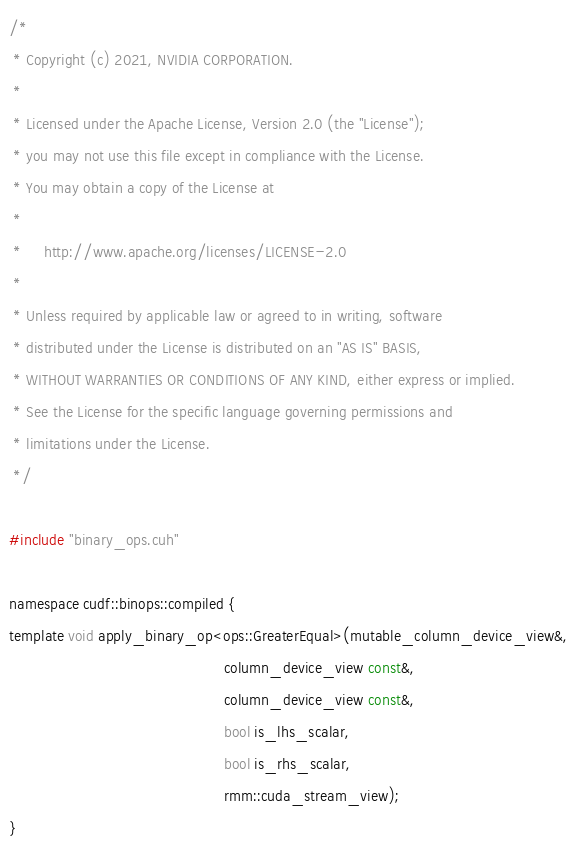<code> <loc_0><loc_0><loc_500><loc_500><_Cuda_>/*
 * Copyright (c) 2021, NVIDIA CORPORATION.
 *
 * Licensed under the Apache License, Version 2.0 (the "License");
 * you may not use this file except in compliance with the License.
 * You may obtain a copy of the License at
 *
 *     http://www.apache.org/licenses/LICENSE-2.0
 *
 * Unless required by applicable law or agreed to in writing, software
 * distributed under the License is distributed on an "AS IS" BASIS,
 * WITHOUT WARRANTIES OR CONDITIONS OF ANY KIND, either express or implied.
 * See the License for the specific language governing permissions and
 * limitations under the License.
 */

#include "binary_ops.cuh"

namespace cudf::binops::compiled {
template void apply_binary_op<ops::GreaterEqual>(mutable_column_device_view&,
                                                 column_device_view const&,
                                                 column_device_view const&,
                                                 bool is_lhs_scalar,
                                                 bool is_rhs_scalar,
                                                 rmm::cuda_stream_view);
}
</code> 